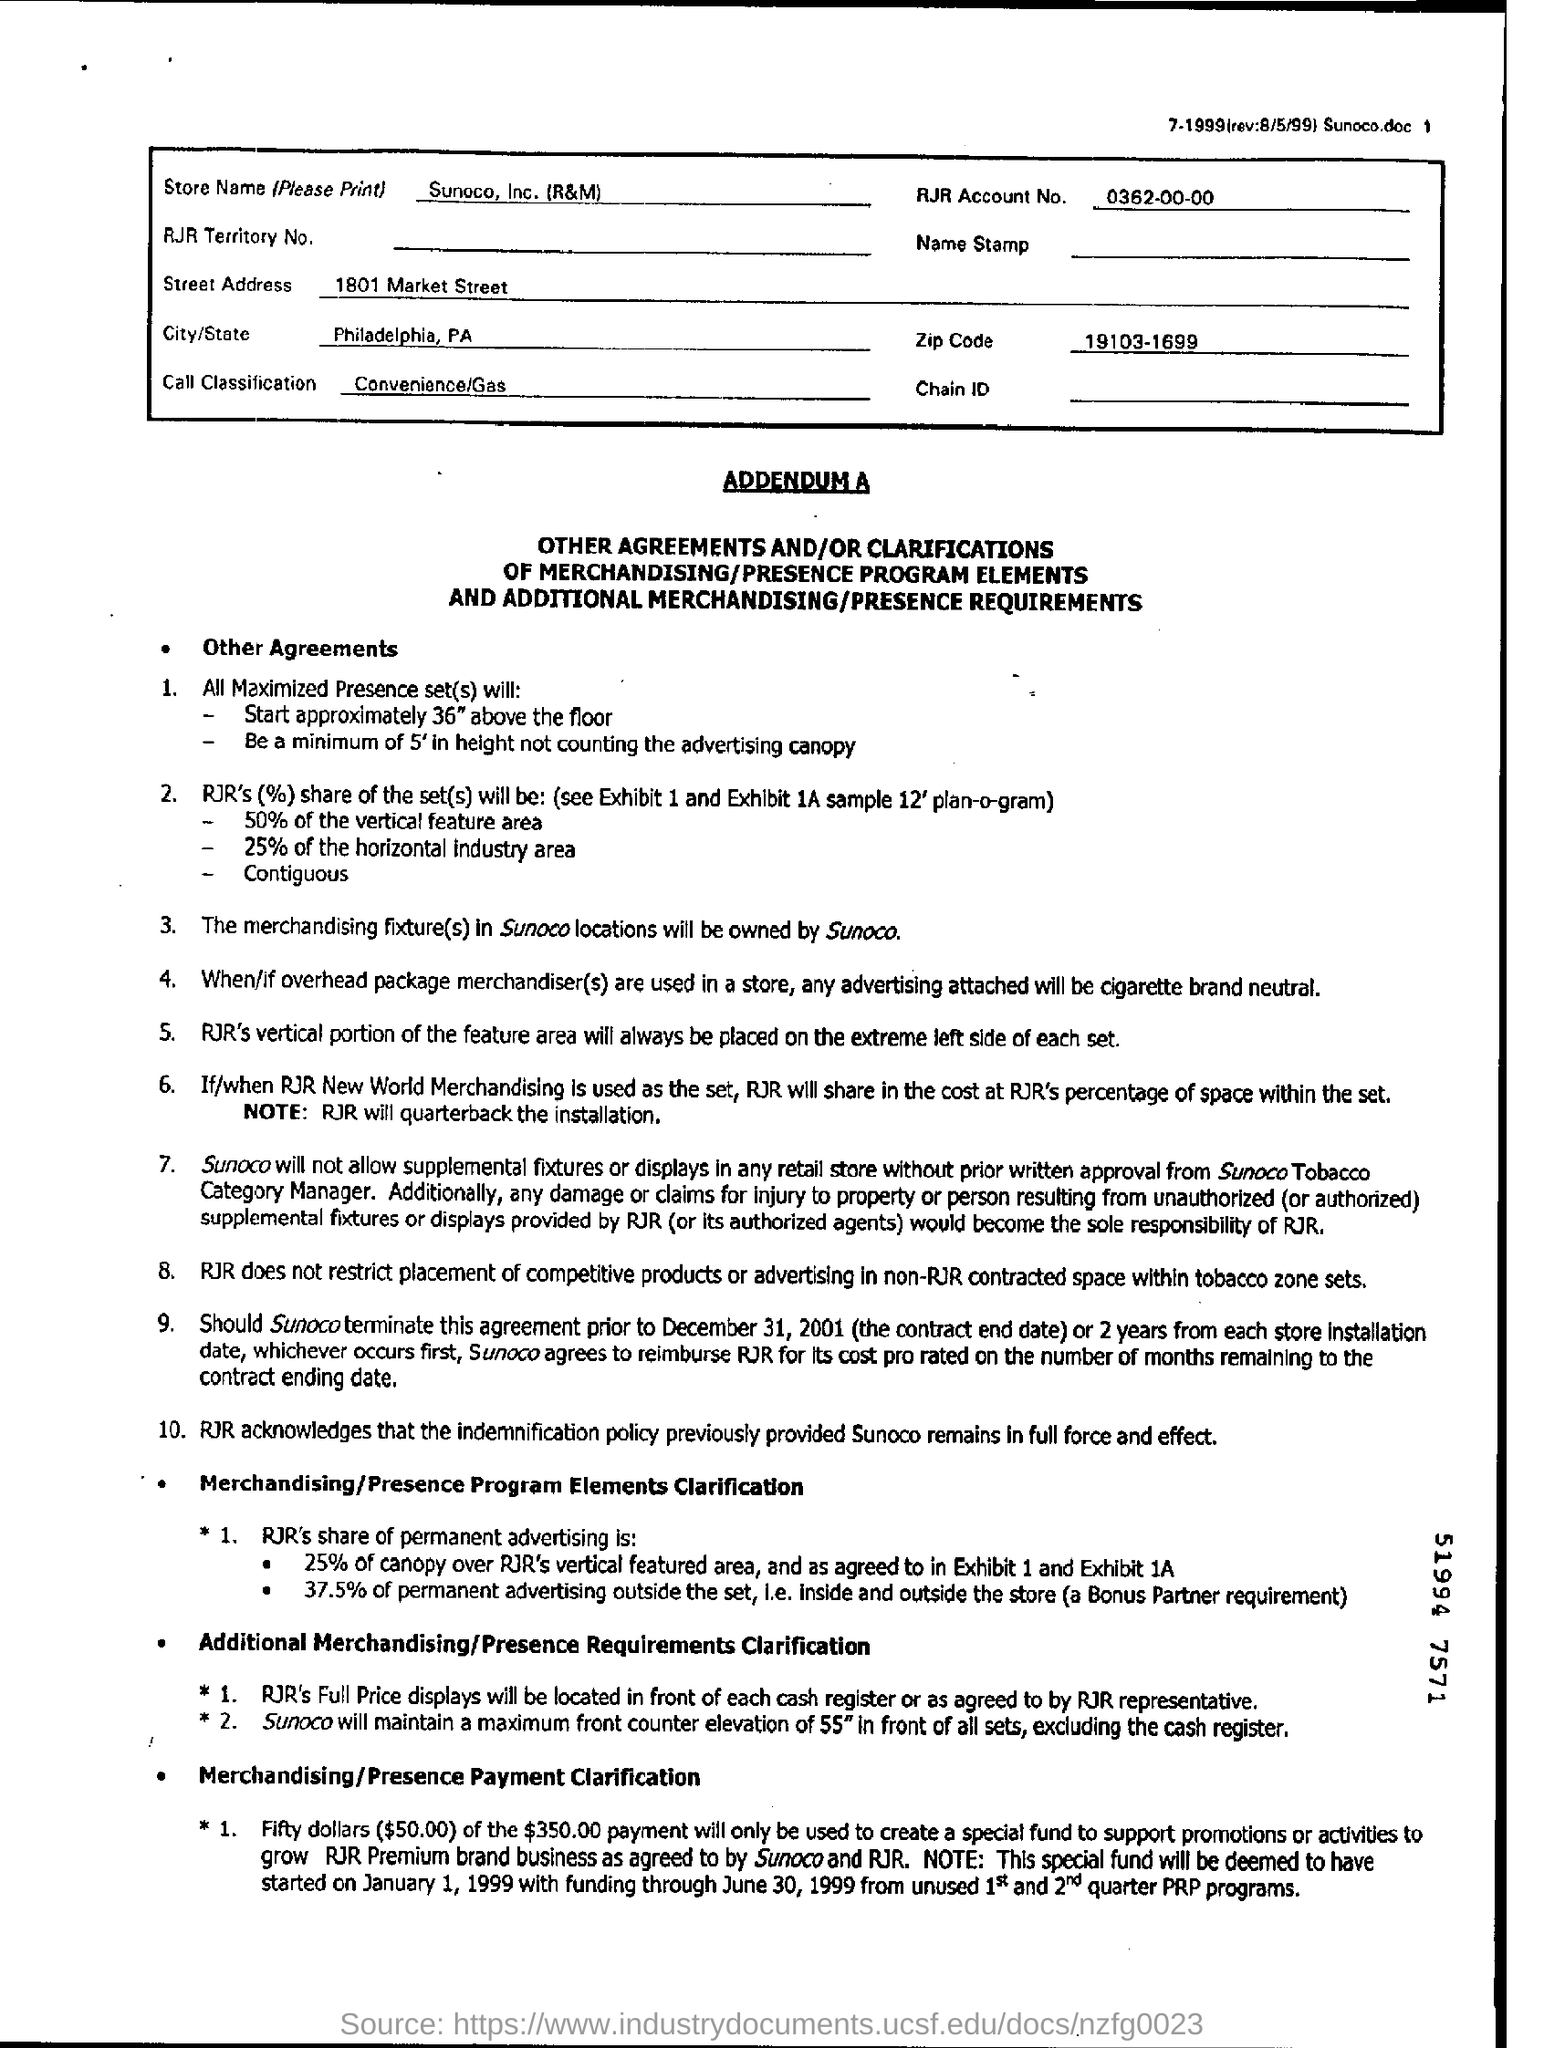What is the name of the Store?
Ensure brevity in your answer.  Sunoco, Inc. (R&M). What is the RJR Account number?
Provide a succinct answer. 0362-00-00. 